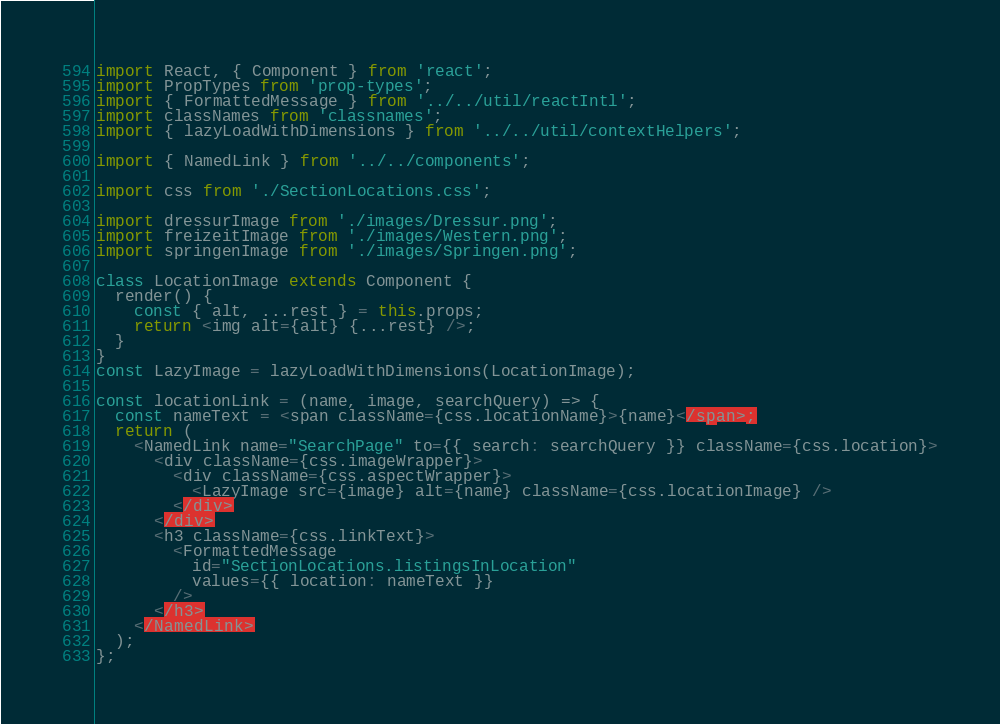Convert code to text. <code><loc_0><loc_0><loc_500><loc_500><_JavaScript_>import React, { Component } from 'react';
import PropTypes from 'prop-types';
import { FormattedMessage } from '../../util/reactIntl';
import classNames from 'classnames';
import { lazyLoadWithDimensions } from '../../util/contextHelpers';

import { NamedLink } from '../../components';

import css from './SectionLocations.css';

import dressurImage from './images/Dressur.png';
import freizeitImage from './images/Western.png';
import springenImage from './images/Springen.png';

class LocationImage extends Component {
  render() {
    const { alt, ...rest } = this.props;
    return <img alt={alt} {...rest} />;
  }
}
const LazyImage = lazyLoadWithDimensions(LocationImage);

const locationLink = (name, image, searchQuery) => {
  const nameText = <span className={css.locationName}>{name}</span>;
  return (
    <NamedLink name="SearchPage" to={{ search: searchQuery }} className={css.location}>
      <div className={css.imageWrapper}>
        <div className={css.aspectWrapper}>
          <LazyImage src={image} alt={name} className={css.locationImage} />
        </div>
      </div>
      <h3 className={css.linkText}>
        <FormattedMessage
          id="SectionLocations.listingsInLocation"
          values={{ location: nameText }}
        />
      </h3>
    </NamedLink>
  );
};
</code> 